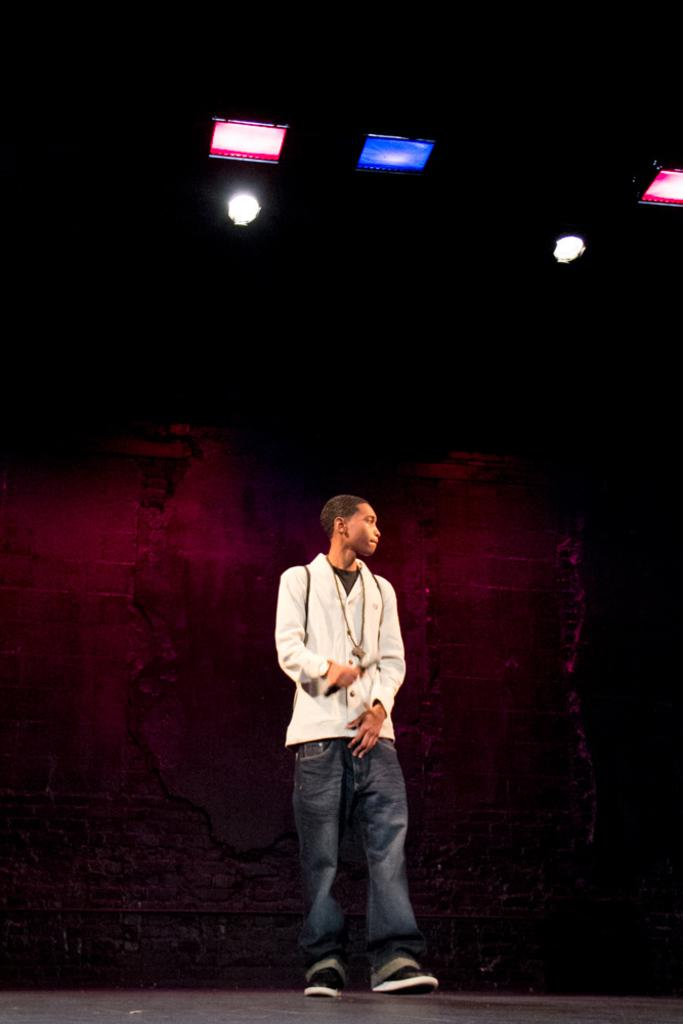What is the main subject of the image? There is a person standing in the center of the image. What can be seen in the background of the image? There is a wall in the background of the image. What is visible at the top of the image? There are lights visible at the top of the image. What is visible at the bottom of the image? There is a floor visible at the bottom of the image. How many chickens are present in the image? There are no chickens present in the image. What type of grain is being used to make the glass in the image? There is no grain or glass present in the image. 